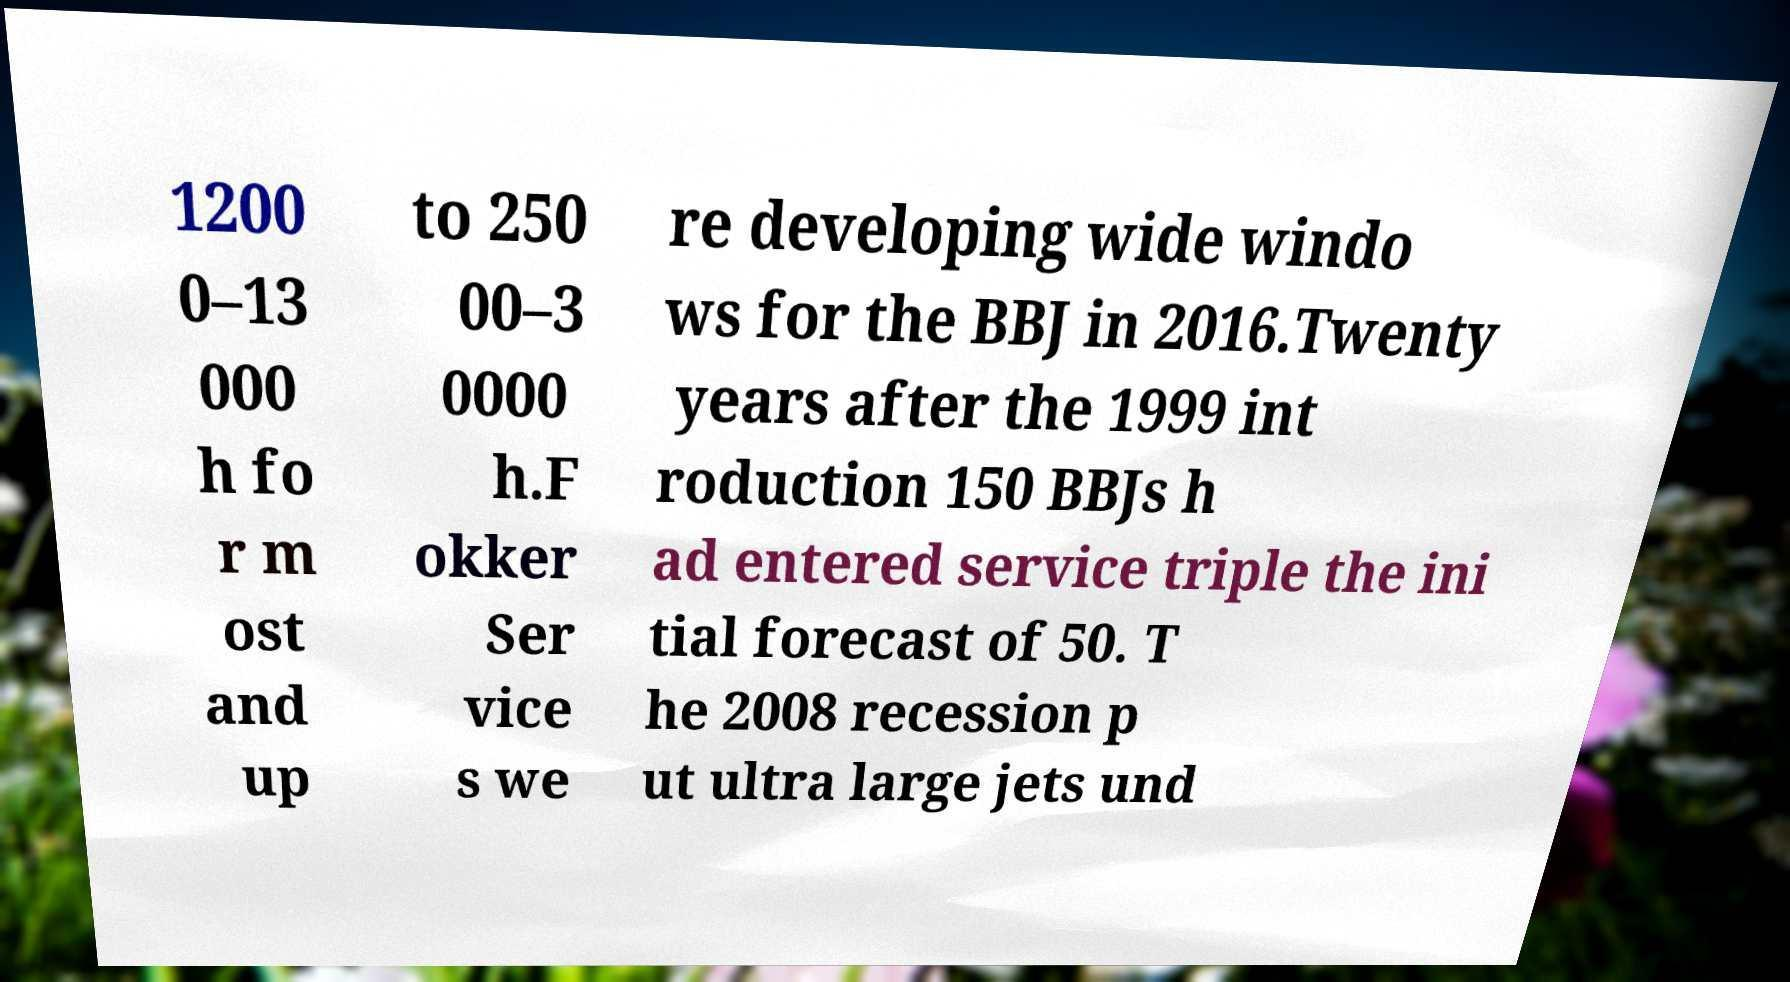I need the written content from this picture converted into text. Can you do that? 1200 0–13 000 h fo r m ost and up to 250 00–3 0000 h.F okker Ser vice s we re developing wide windo ws for the BBJ in 2016.Twenty years after the 1999 int roduction 150 BBJs h ad entered service triple the ini tial forecast of 50. T he 2008 recession p ut ultra large jets und 